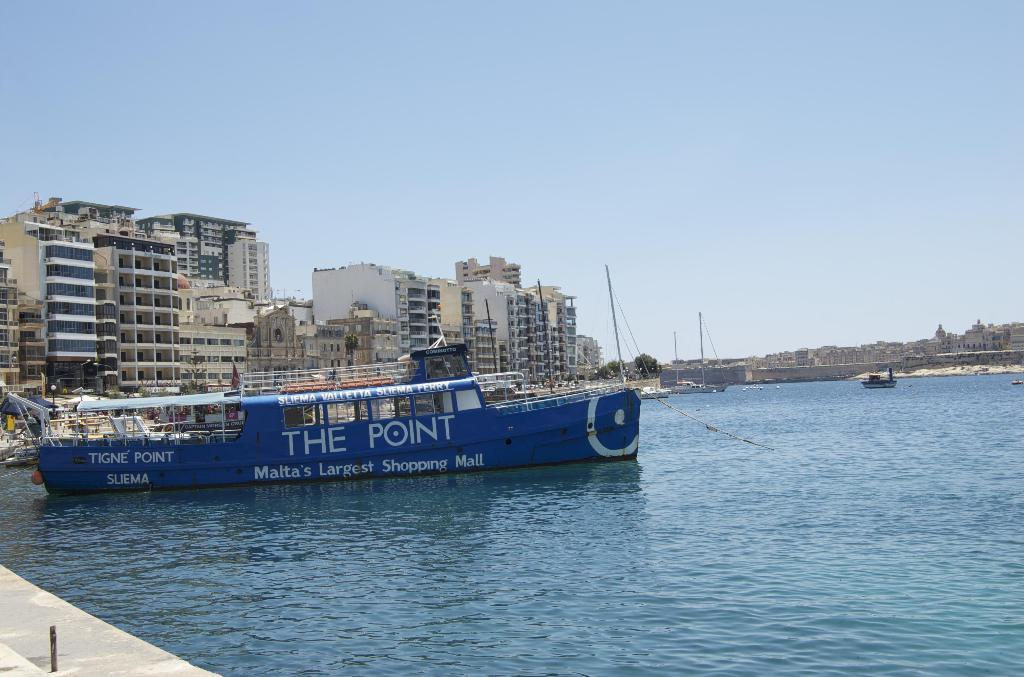<image>
Write a terse but informative summary of the picture. the words the point that are on a ship 